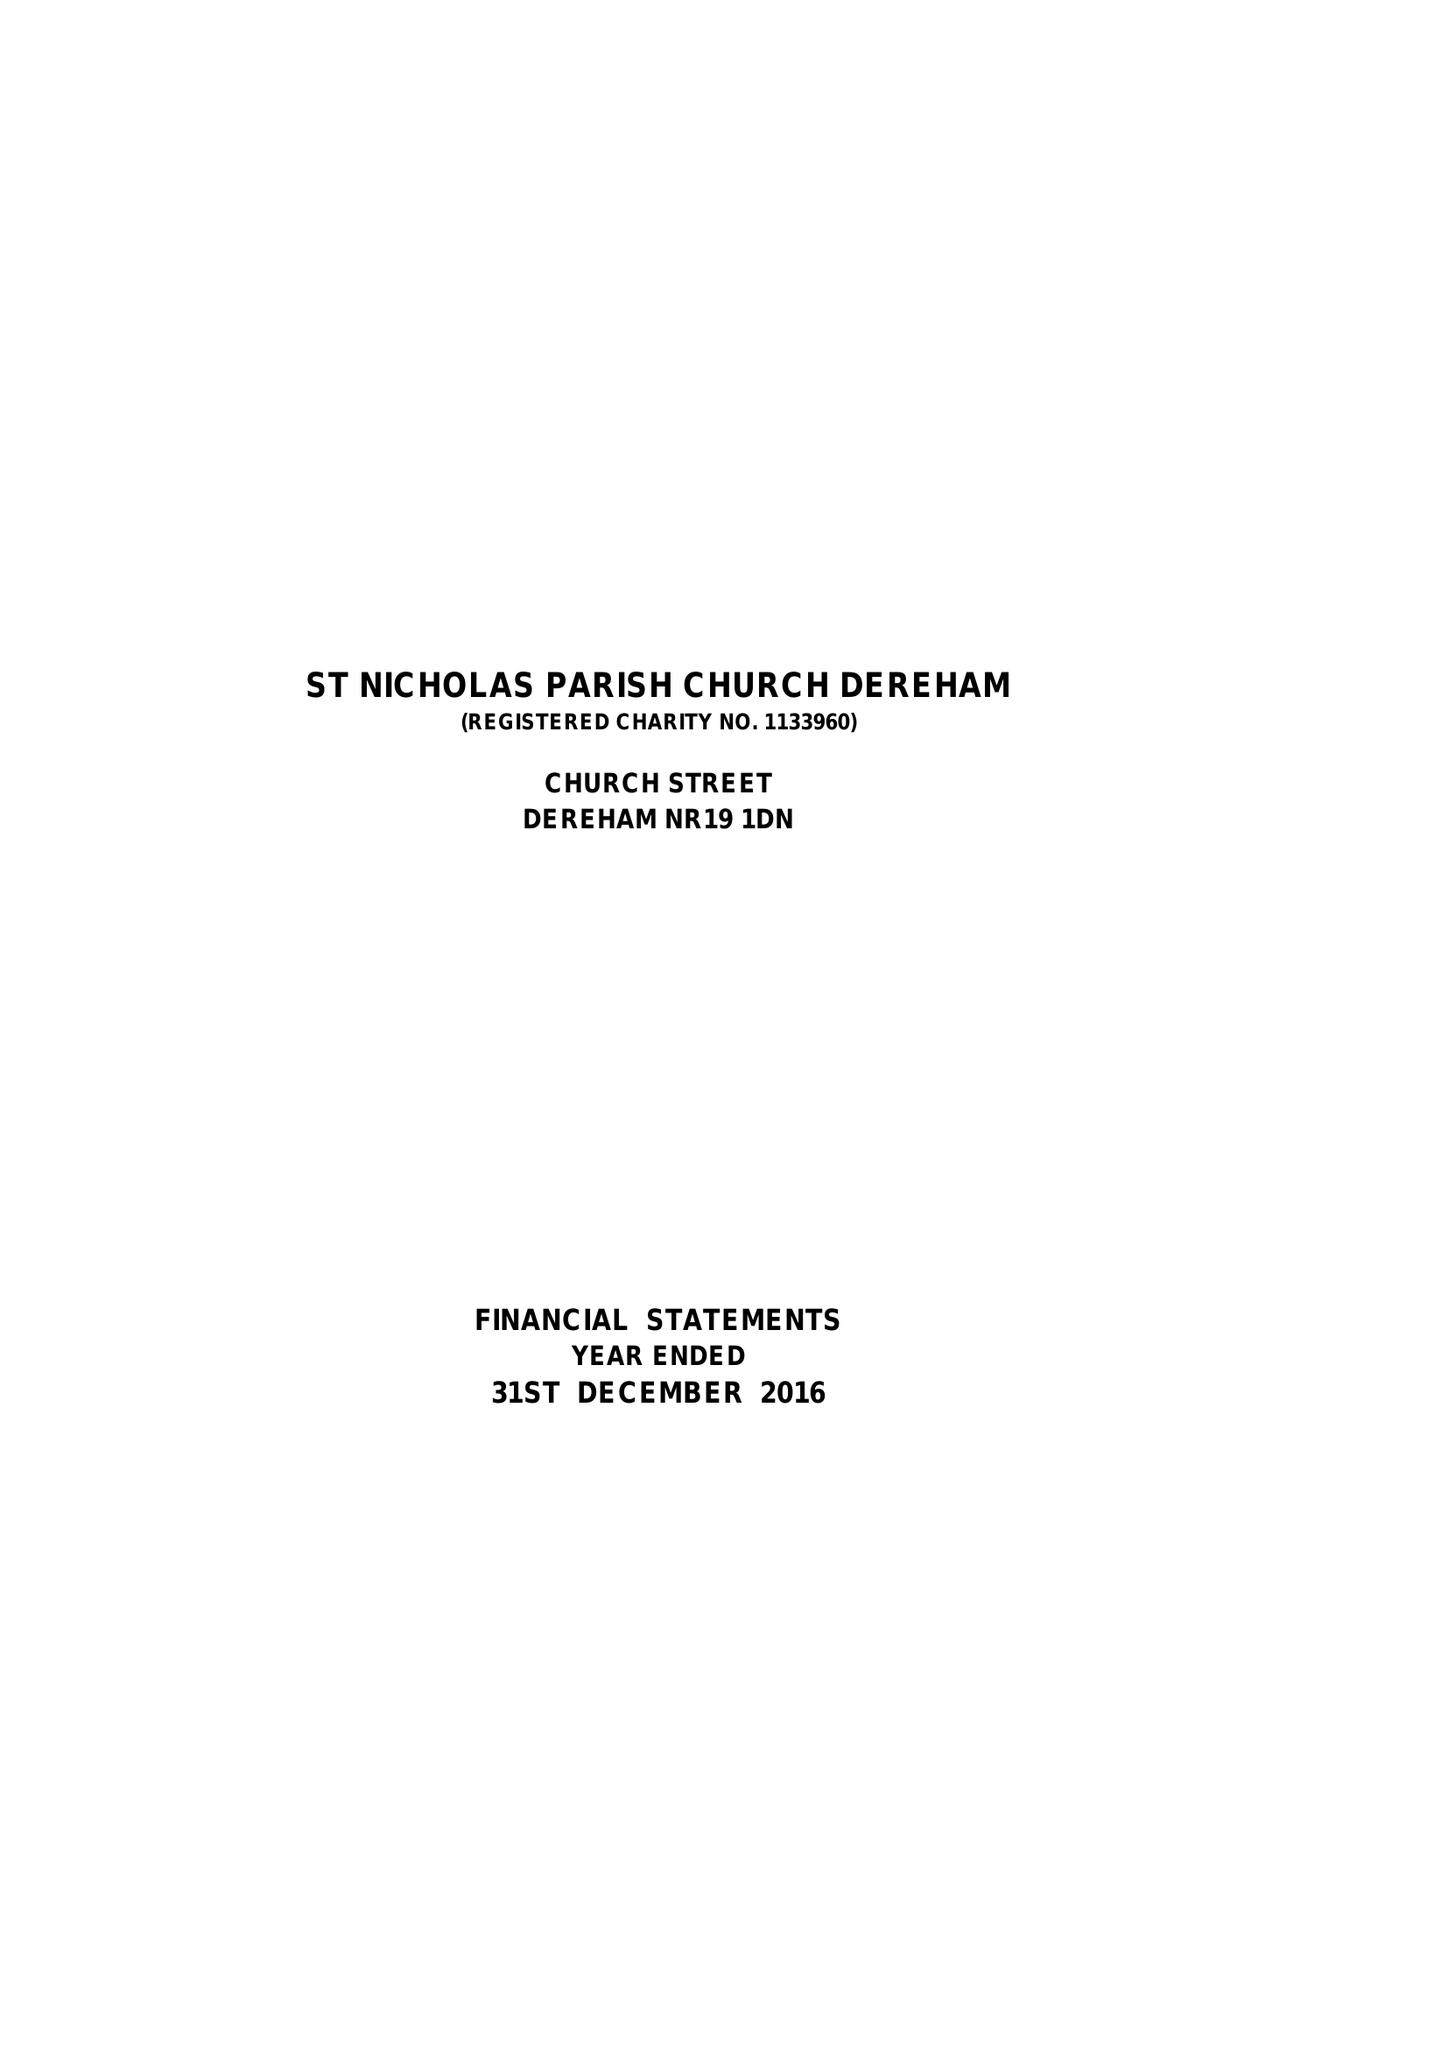What is the value for the address__postcode?
Answer the question using a single word or phrase. NR19 1DN 